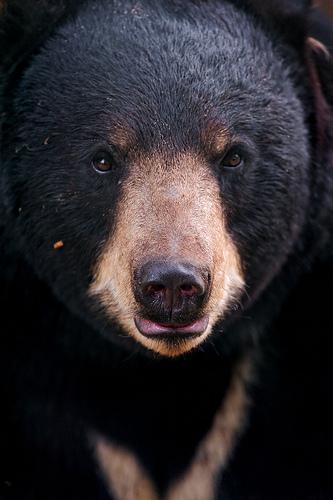How many animals are pictured?
Give a very brief answer. 1. 